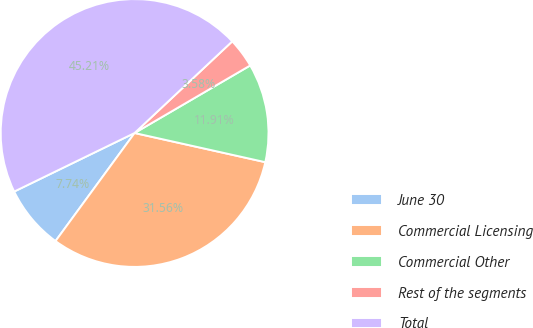Convert chart. <chart><loc_0><loc_0><loc_500><loc_500><pie_chart><fcel>June 30<fcel>Commercial Licensing<fcel>Commercial Other<fcel>Rest of the segments<fcel>Total<nl><fcel>7.74%<fcel>31.56%<fcel>11.91%<fcel>3.58%<fcel>45.21%<nl></chart> 